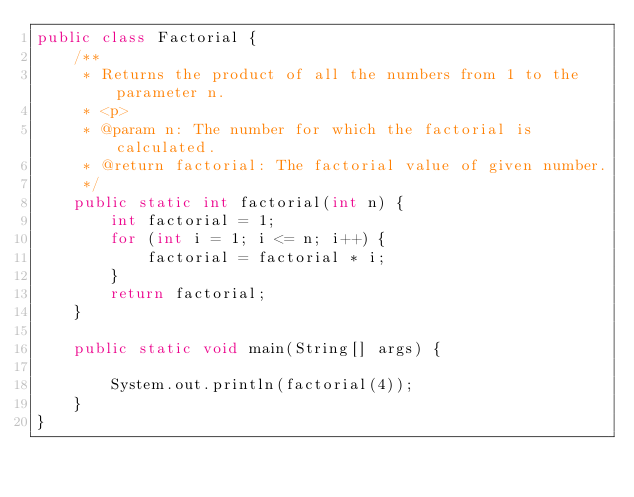<code> <loc_0><loc_0><loc_500><loc_500><_Java_>public class Factorial {    
    /**
     * Returns the product of all the numbers from 1 to the parameter n.
     * <p> 
     * @param n: The number for which the factorial is calculated.
     * @return factorial: The factorial value of given number.
     */
    public static int factorial(int n) {
        int factorial = 1;
        for (int i = 1; i <= n; i++) {
            factorial = factorial * i;
        }
        return factorial;
    }

    public static void main(String[] args) {

        System.out.println(factorial(4));
    }
}
</code> 